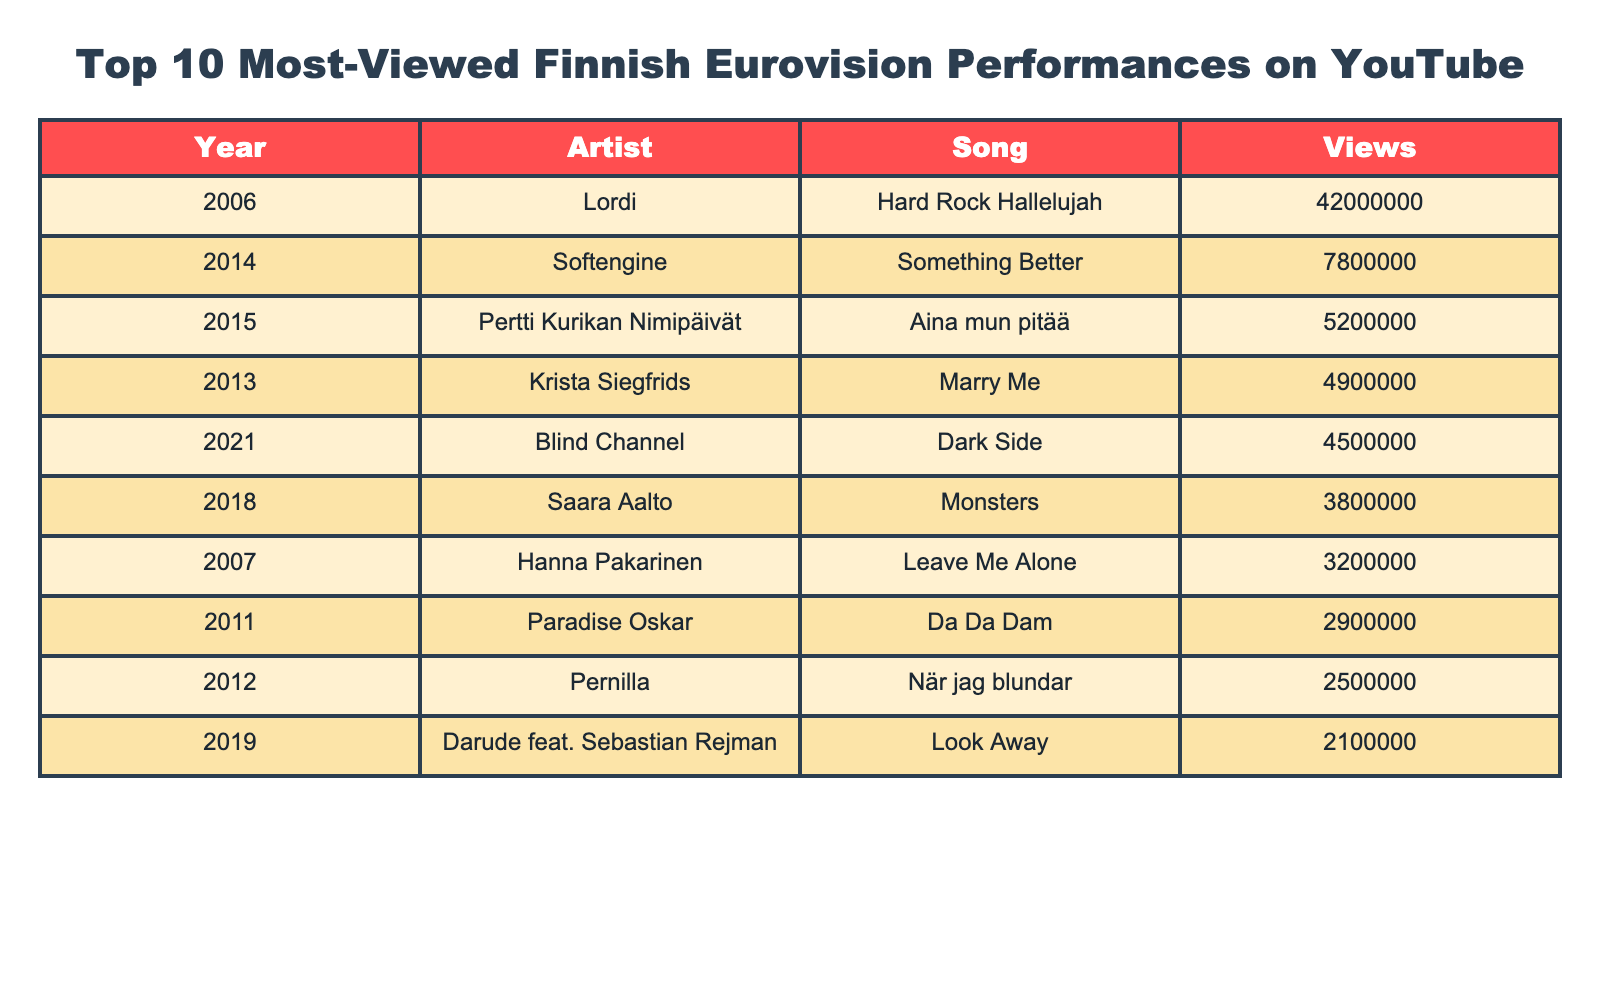What is the most viewed Finnish Eurovision performance on YouTube? The table shows that Lordi's "Hard Rock Hallelujah" has the highest views, with 42,000,000 views.
Answer: 42,000,000 Which year did the entry with the least views participate in Eurovision? The entry with the least views is Darude feat. Sebastian Rejman's "Look Away," recorded in 2019, with 2,100,000 views.
Answer: 2019 How many views did Saara Aalto from 2018 receive? According to the table, Saara Aalto's performance "Monsters" received 3,800,000 views.
Answer: 3,800,000 What is the total number of views for the entries from 2014 and 2015? Adding the views from 2014 (Softengine - 7,800,000) and 2015 (Pertti Kurikan Nimipäivät - 5,200,000) gives 7,800,000 + 5,200,000 = 13,000,000 views.
Answer: 13,000,000 Is the performance of Krista Siegfrids more viewed than that of Blind Channel? Krista Siegfrids' performance "Marry Me" has 4,900,000 views, while Blind Channel's "Dark Side" has 4,500,000 views, confirming that Krista's performance is more viewed.
Answer: Yes What is the average number of views for the top three performances listed? The top three performances have views of 42,000,000 (Lordi), 7,800,000 (Softengine), and 5,200,000 (Pertti Kurikan Nimipäivät). The total is 42,000,000 + 7,800,000 + 5,200,000 = 55,000,000 views. Dividing by 3 gives an average of 55,000,000 / 3 = 18,333,333.33.
Answer: 18,333,333 Which artist had a performance that received more than 3 million views but less than 5 million views? The entries for Krista Siegfrids (4,900,000 views), Blind Channel (4,500,000 views), and Saara Aalto (3,800,000 views) fit this criterion.
Answer: Krista Siegfrids, Blind Channel, Saara Aalto How many entries had views greater than 3 million but less than 4 million? Only one entry fits this, which is Saara Aalto with 3,800,000 views.
Answer: 1 What percentage of the total views does "Hard Rock Hallelujah" represent among the top 10 performances? The total views for all performances are 42,000,000 + 7,800,000 + 5,200,000 + 4,900,000 + 4,500,000 + 3,800,000 + 3,200,000 + 2,900,000 + 2,500,000 + 2,100,000 = 73,100,000 views. The percentage of Lordi's views is (42,000,000 / 73,100,000) * 100 ≈ 57.4%.
Answer: 57.4% Which Finnish Eurovision entry had the highest views in the 2010s decade? The entry with the highest views in the 2010s is Softengine's "Something Better" from 2014 with 7,800,000 views.
Answer: Softengine's "Something Better" 